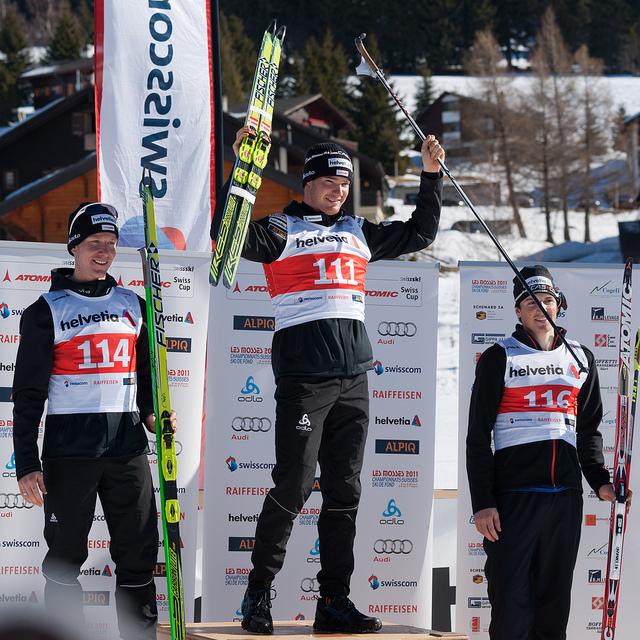Winter or summer?
Keep it brief. Winter. What number is the winner wearing?
Give a very brief answer. 111. What sport is depicted?
Answer briefly. Skiing. 